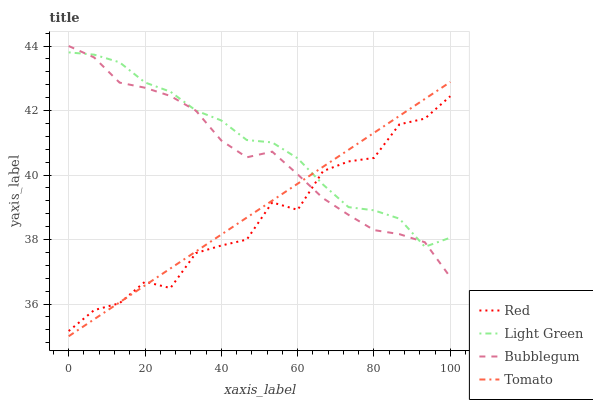Does Red have the minimum area under the curve?
Answer yes or no. Yes. Does Light Green have the maximum area under the curve?
Answer yes or no. Yes. Does Bubblegum have the minimum area under the curve?
Answer yes or no. No. Does Bubblegum have the maximum area under the curve?
Answer yes or no. No. Is Tomato the smoothest?
Answer yes or no. Yes. Is Red the roughest?
Answer yes or no. Yes. Is Bubblegum the smoothest?
Answer yes or no. No. Is Bubblegum the roughest?
Answer yes or no. No. Does Tomato have the lowest value?
Answer yes or no. Yes. Does Bubblegum have the lowest value?
Answer yes or no. No. Does Bubblegum have the highest value?
Answer yes or no. Yes. Does Light Green have the highest value?
Answer yes or no. No. Does Light Green intersect Red?
Answer yes or no. Yes. Is Light Green less than Red?
Answer yes or no. No. Is Light Green greater than Red?
Answer yes or no. No. 